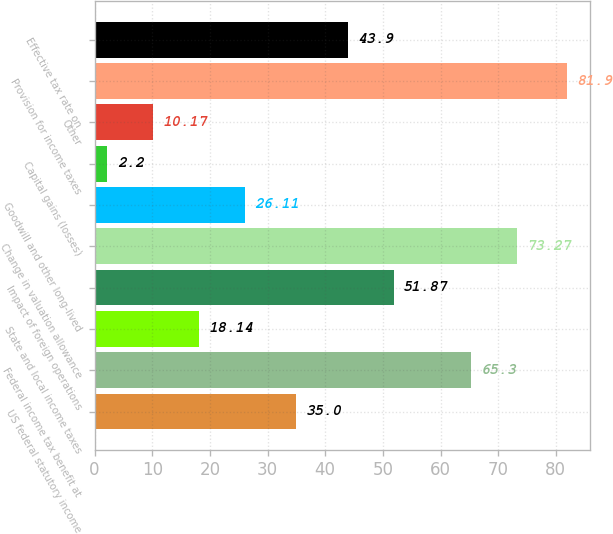Convert chart. <chart><loc_0><loc_0><loc_500><loc_500><bar_chart><fcel>US federal statutory income<fcel>Federal income tax benefit at<fcel>State and local income taxes<fcel>Impact of foreign operations<fcel>Change in valuation allowance<fcel>Goodwill and other long-lived<fcel>Capital gains (losses)<fcel>Other<fcel>Provision for income taxes<fcel>Effective tax rate on<nl><fcel>35<fcel>65.3<fcel>18.14<fcel>51.87<fcel>73.27<fcel>26.11<fcel>2.2<fcel>10.17<fcel>81.9<fcel>43.9<nl></chart> 